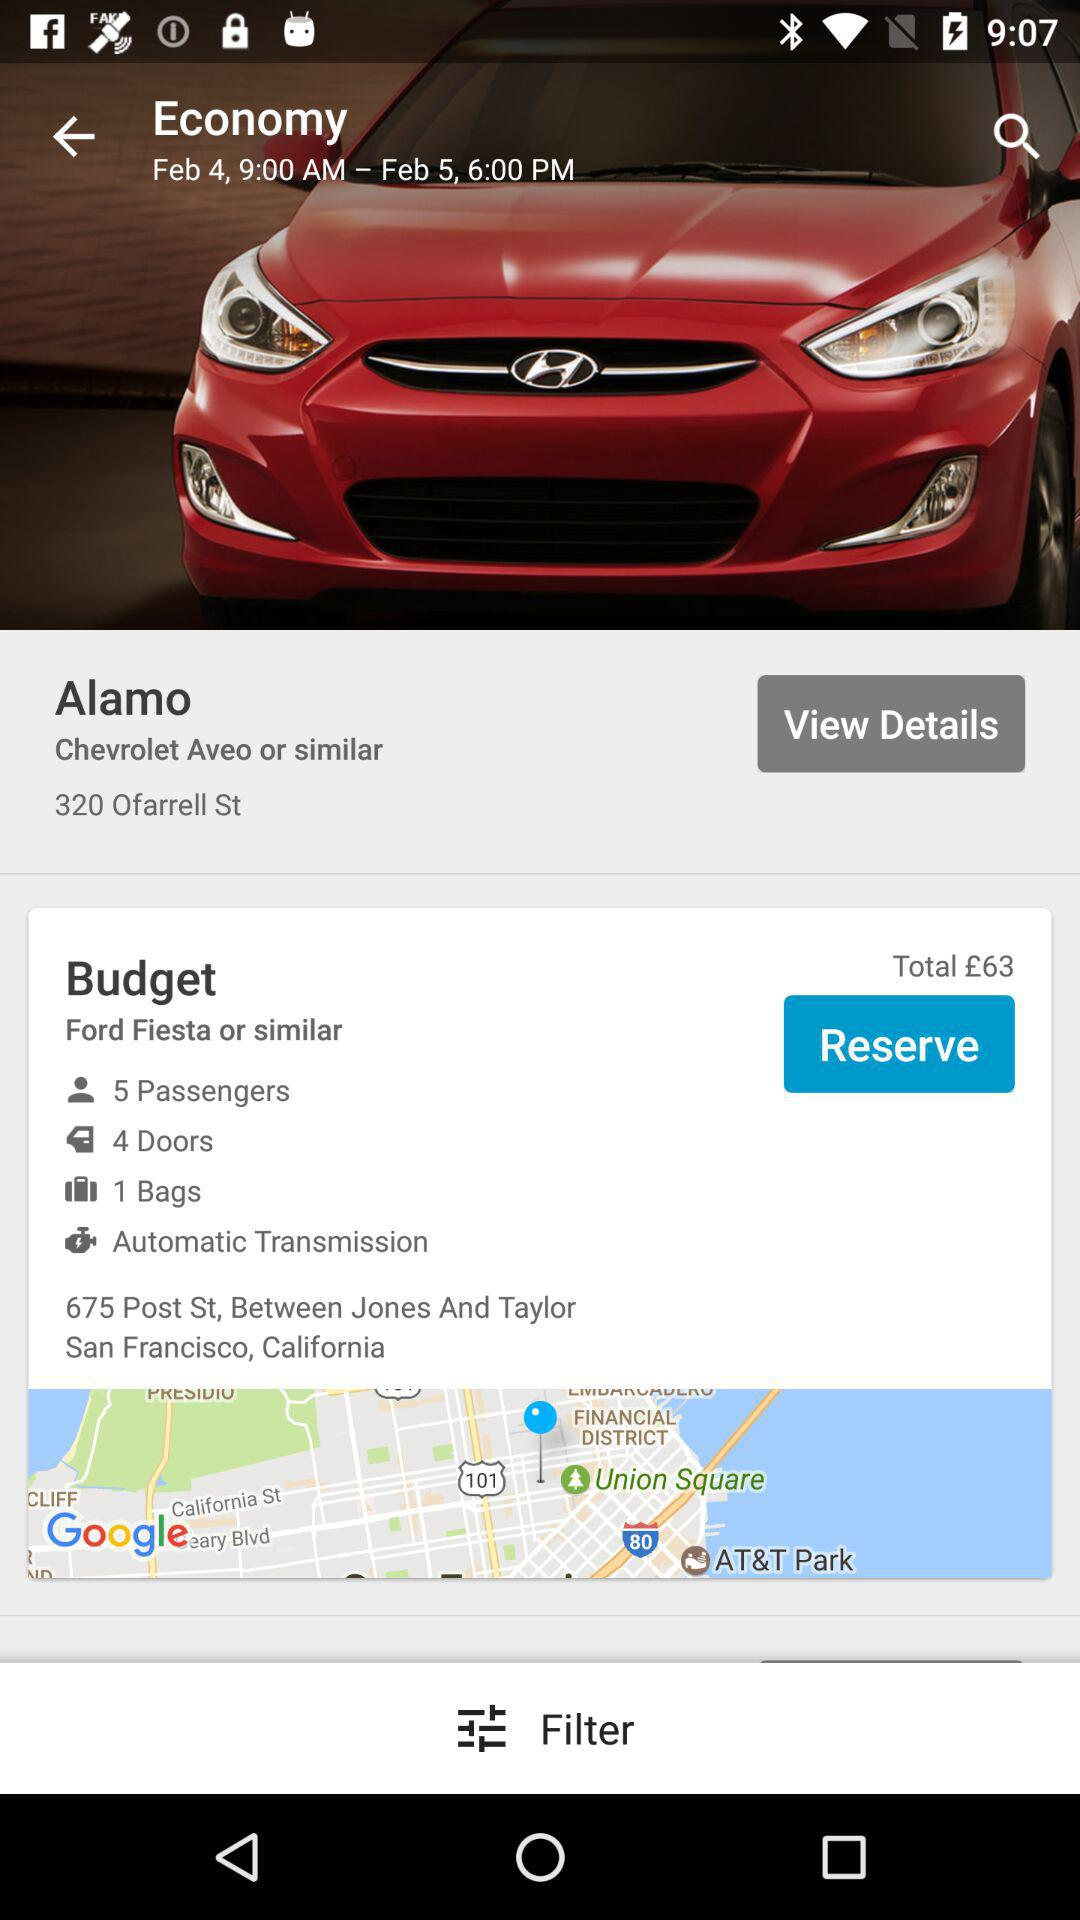What is the address? The address is 675 Post St, Between Jones And Taylor San Francisco, California. 